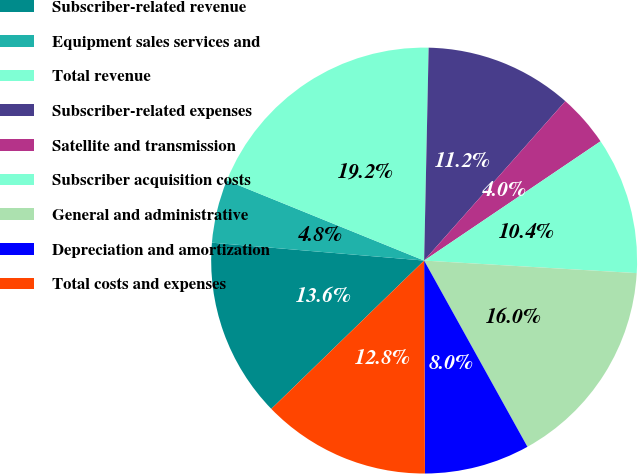Convert chart. <chart><loc_0><loc_0><loc_500><loc_500><pie_chart><fcel>Subscriber-related revenue<fcel>Equipment sales services and<fcel>Total revenue<fcel>Subscriber-related expenses<fcel>Satellite and transmission<fcel>Subscriber acquisition costs<fcel>General and administrative<fcel>Depreciation and amortization<fcel>Total costs and expenses<nl><fcel>13.6%<fcel>4.8%<fcel>19.2%<fcel>11.2%<fcel>4.0%<fcel>10.4%<fcel>16.0%<fcel>8.0%<fcel>12.8%<nl></chart> 